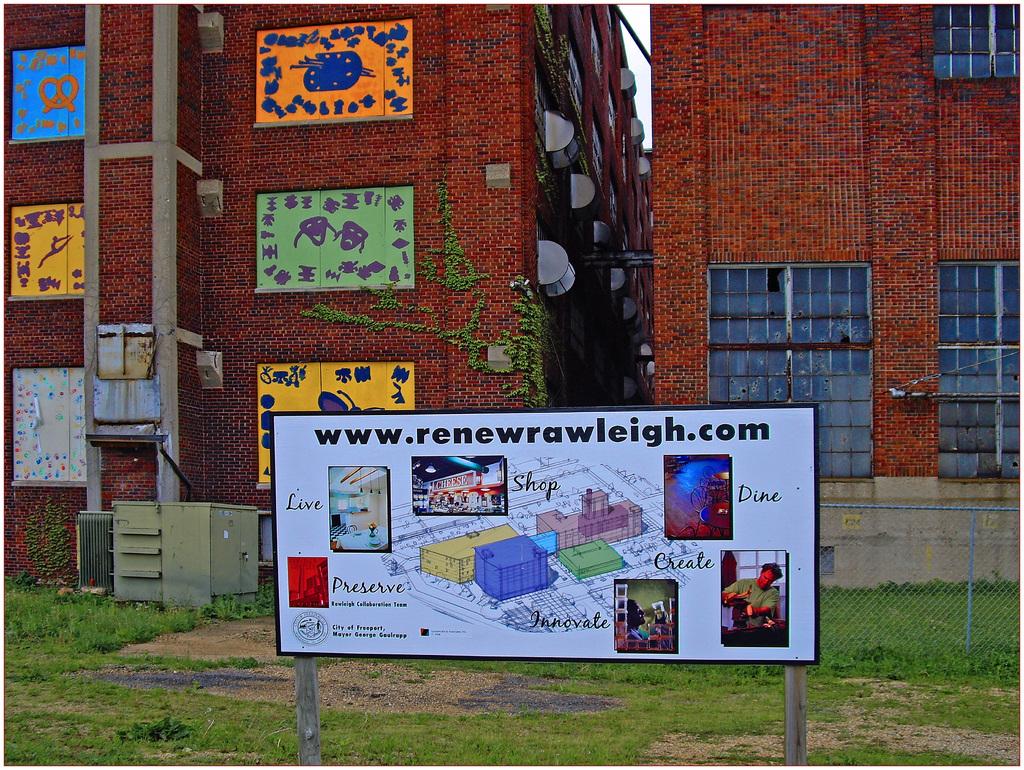What website is on the sign?
Offer a terse response. Www.renewrawleigh.com. What product name is on the picture beside the word shop?
Keep it short and to the point. Cheese. 